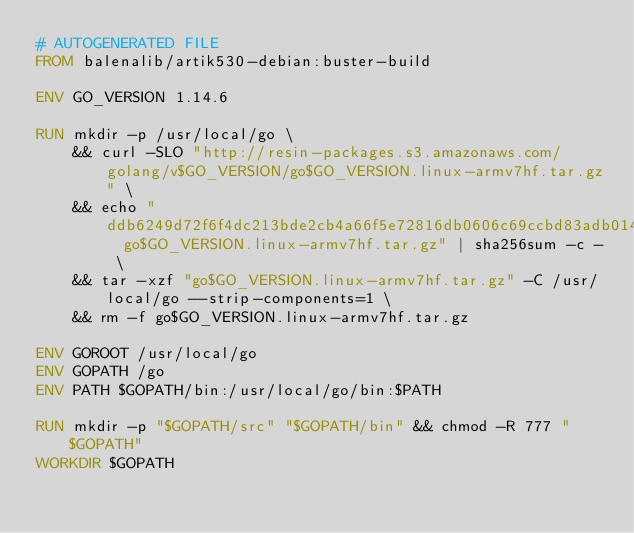<code> <loc_0><loc_0><loc_500><loc_500><_Dockerfile_># AUTOGENERATED FILE
FROM balenalib/artik530-debian:buster-build

ENV GO_VERSION 1.14.6

RUN mkdir -p /usr/local/go \
	&& curl -SLO "http://resin-packages.s3.amazonaws.com/golang/v$GO_VERSION/go$GO_VERSION.linux-armv7hf.tar.gz" \
	&& echo "ddb6249d72f6f4dc213bde2cb4a66f5e72816db0606c69ccbd83adb0148912b8  go$GO_VERSION.linux-armv7hf.tar.gz" | sha256sum -c - \
	&& tar -xzf "go$GO_VERSION.linux-armv7hf.tar.gz" -C /usr/local/go --strip-components=1 \
	&& rm -f go$GO_VERSION.linux-armv7hf.tar.gz

ENV GOROOT /usr/local/go
ENV GOPATH /go
ENV PATH $GOPATH/bin:/usr/local/go/bin:$PATH

RUN mkdir -p "$GOPATH/src" "$GOPATH/bin" && chmod -R 777 "$GOPATH"
WORKDIR $GOPATH
</code> 